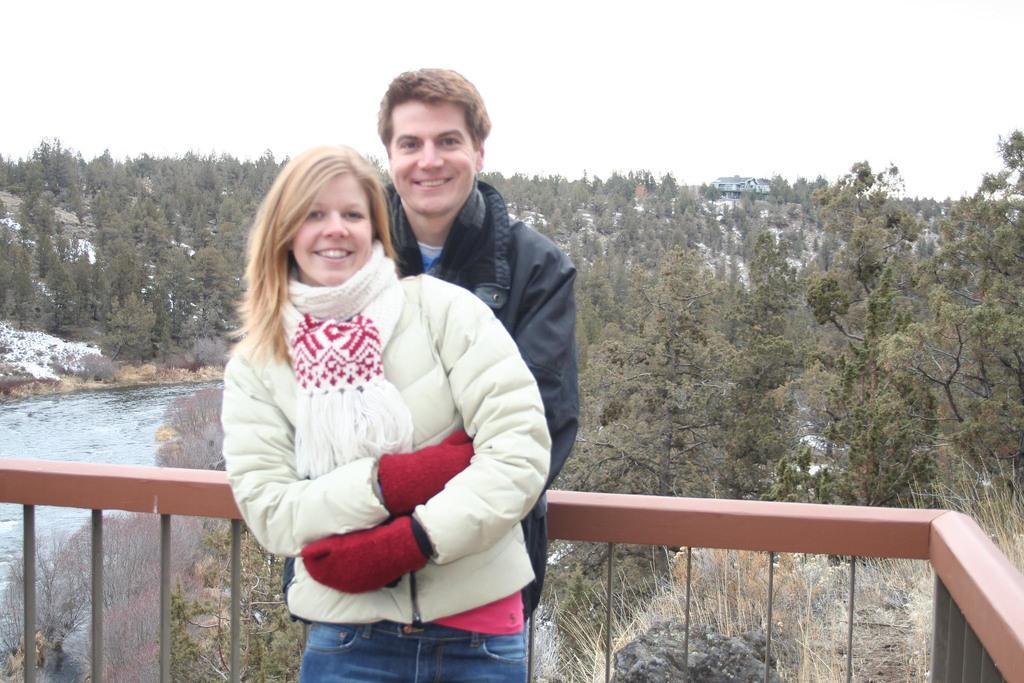Can you describe this image briefly? In the image there is a woman white jacket and scarf standing in front of man in black jacket, there is fence on either side, behind them there are trees all over the land with canal on the left side and above its sky. 